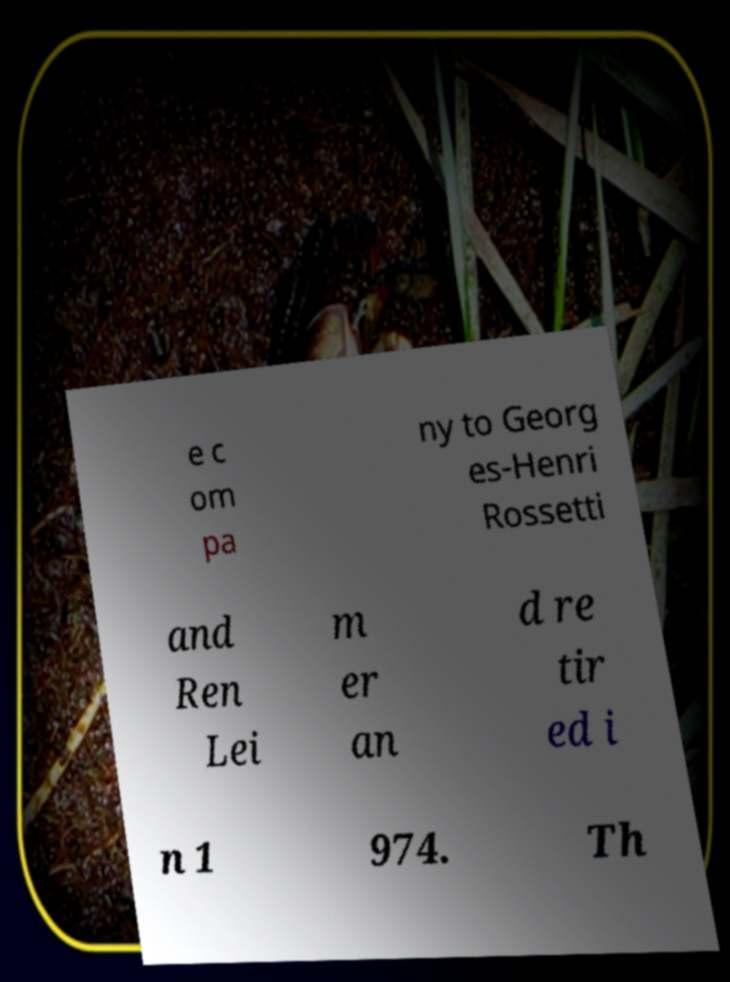Can you accurately transcribe the text from the provided image for me? e c om pa ny to Georg es-Henri Rossetti and Ren Lei m er an d re tir ed i n 1 974. Th 